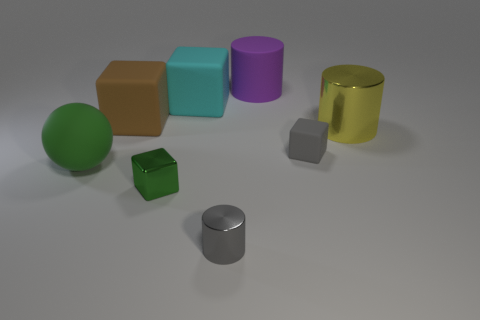Subtract 1 blocks. How many blocks are left? 3 Add 1 cyan rubber cubes. How many objects exist? 9 Subtract all cylinders. How many objects are left? 5 Subtract 0 purple balls. How many objects are left? 8 Subtract all red shiny cylinders. Subtract all small gray matte things. How many objects are left? 7 Add 6 large matte spheres. How many large matte spheres are left? 7 Add 7 gray objects. How many gray objects exist? 9 